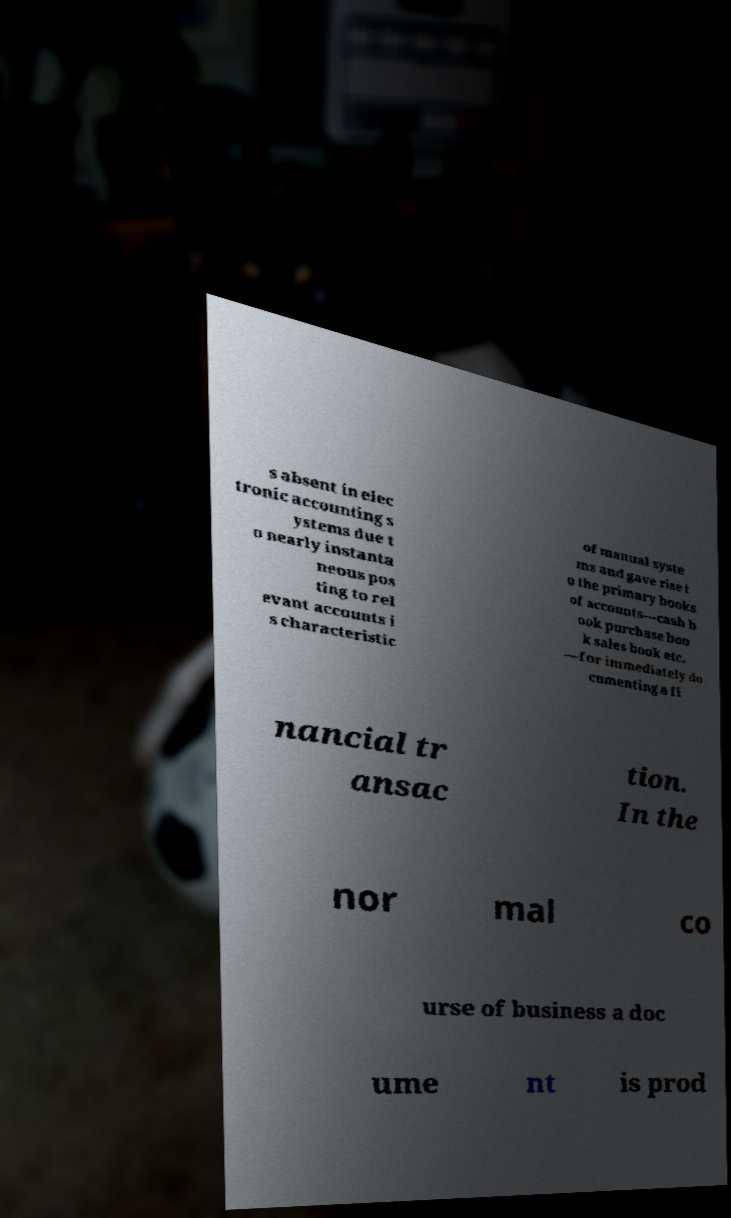Could you assist in decoding the text presented in this image and type it out clearly? s absent in elec tronic accounting s ystems due t o nearly instanta neous pos ting to rel evant accounts i s characteristic of manual syste ms and gave rise t o the primary books of accounts—cash b ook purchase boo k sales book etc. —for immediately do cumenting a fi nancial tr ansac tion. In the nor mal co urse of business a doc ume nt is prod 